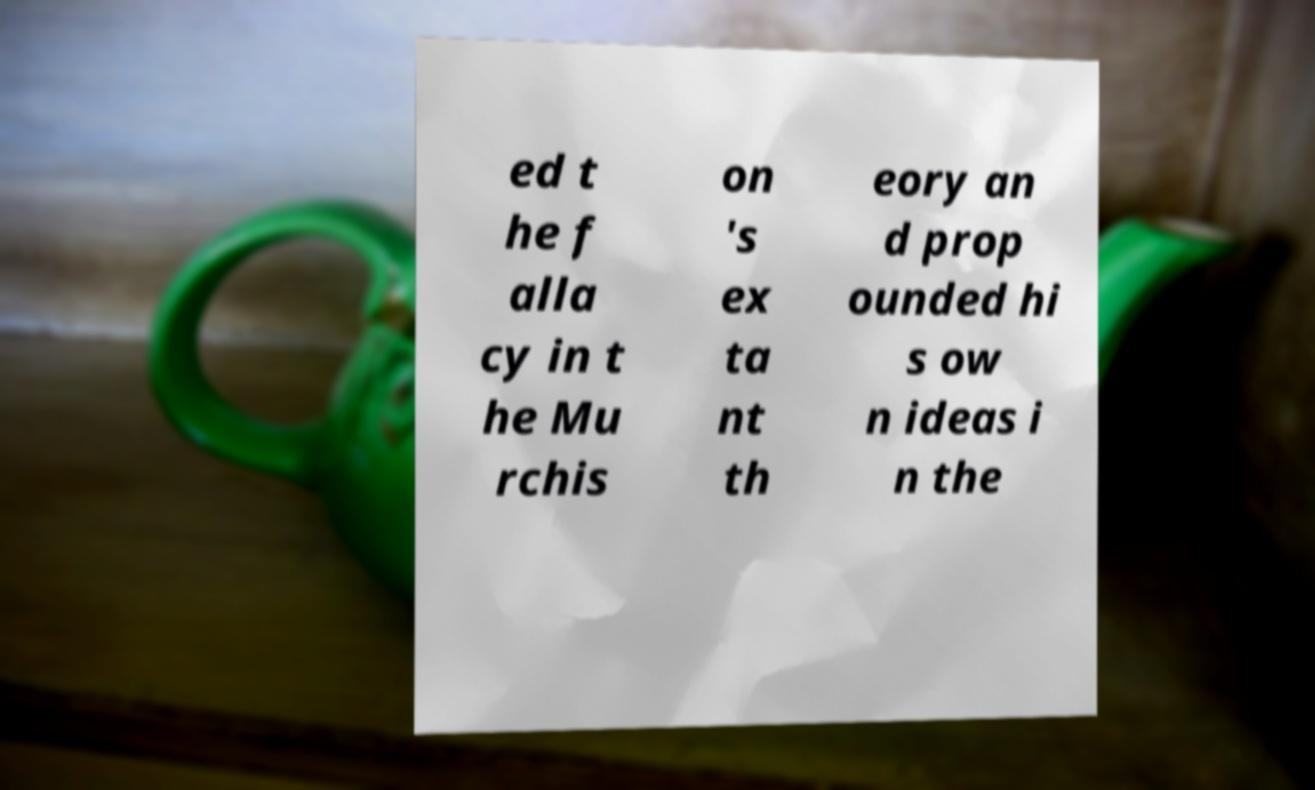There's text embedded in this image that I need extracted. Can you transcribe it verbatim? ed t he f alla cy in t he Mu rchis on 's ex ta nt th eory an d prop ounded hi s ow n ideas i n the 